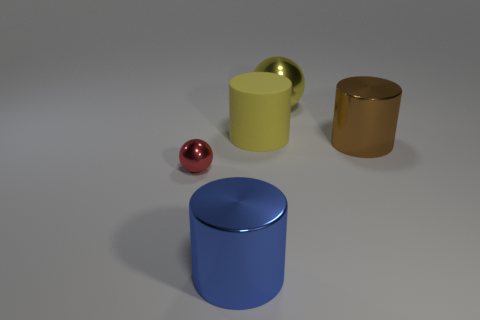Add 1 big brown metal cylinders. How many objects exist? 6 Subtract all balls. How many objects are left? 3 Subtract all small gray things. Subtract all big yellow matte cylinders. How many objects are left? 4 Add 1 big yellow cylinders. How many big yellow cylinders are left? 2 Add 4 big blocks. How many big blocks exist? 4 Subtract 0 purple cubes. How many objects are left? 5 